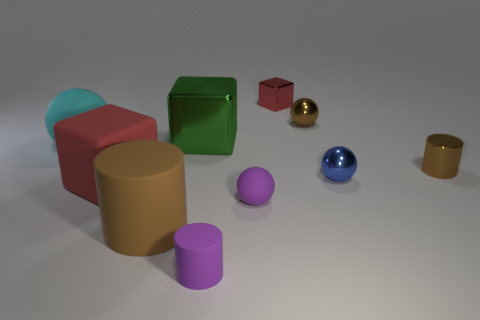How many things are either big green shiny cubes or cylinders?
Provide a succinct answer. 4. Does the red block that is left of the tiny purple sphere have the same size as the metal ball in front of the metal cylinder?
Keep it short and to the point. No. What number of other things are made of the same material as the tiny red cube?
Ensure brevity in your answer.  4. Are there more purple matte spheres on the right side of the large metallic block than brown metal cylinders in front of the red matte cube?
Offer a very short reply. Yes. What material is the tiny sphere that is left of the tiny shiny cube?
Your answer should be compact. Rubber. Does the big red rubber object have the same shape as the large brown matte thing?
Ensure brevity in your answer.  No. Is there anything else of the same color as the tiny block?
Keep it short and to the point. Yes. The tiny thing that is the same shape as the large red thing is what color?
Keep it short and to the point. Red. Are there more brown matte objects behind the brown metallic cylinder than metal cylinders?
Give a very brief answer. No. The big cube in front of the blue sphere is what color?
Offer a terse response. Red. 